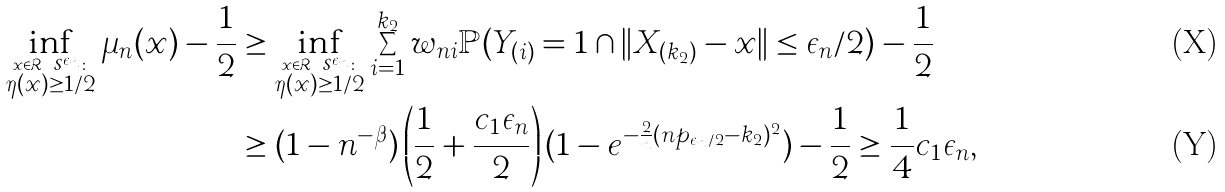Convert formula to latex. <formula><loc_0><loc_0><loc_500><loc_500>\inf _ { \stackrel { x \in \mathcal { R } \ \mathcal { S } ^ { \epsilon _ { n } } \colon } { \eta ( x ) \geq 1 / 2 } } \mu _ { n } ( x ) - \frac { 1 } { 2 } & \geq \inf _ { \stackrel { x \in \mathcal { R } \ \mathcal { S } ^ { \epsilon _ { n } } \colon } { \eta ( x ) \geq 1 / 2 } } \sum _ { i = 1 } ^ { k _ { 2 } } w _ { n i } \mathbb { P } ( Y _ { ( i ) } = 1 \cap \| X _ { ( k _ { 2 } ) } - x \| \leq \epsilon _ { n } / 2 ) - \frac { 1 } { 2 } \\ & \geq ( 1 - n ^ { - \beta } ) \left ( \frac { 1 } { 2 } + \frac { c _ { 1 } \epsilon _ { n } } { 2 } \right ) ( 1 - e ^ { - \frac { 2 } { n } ( n p _ { \epsilon _ { n } / 2 } - k _ { 2 } ) ^ { 2 } } ) - \frac { 1 } { 2 } \geq \frac { 1 } { 4 } c _ { 1 } \epsilon _ { n } ,</formula> 